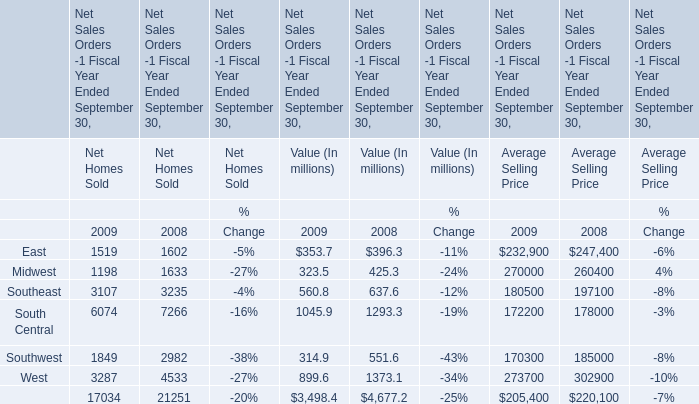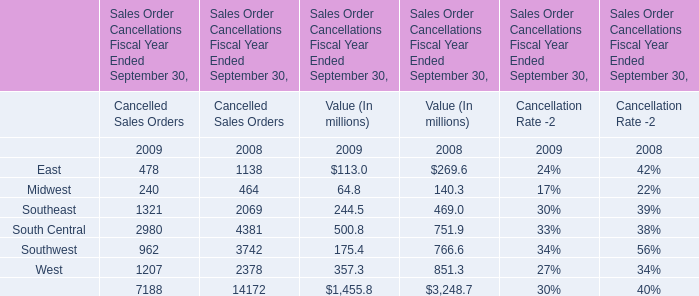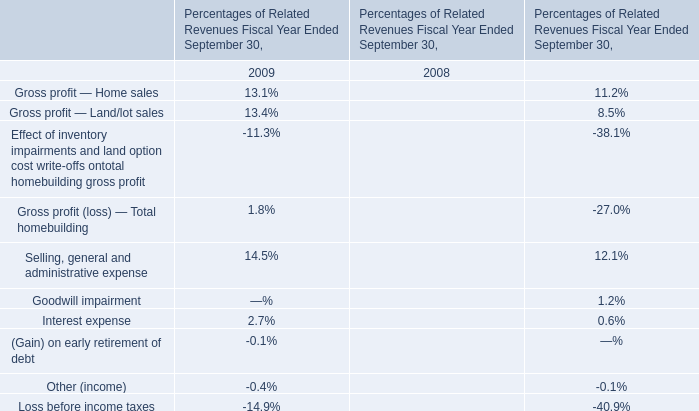What will East for Net Homes Sold reach in 2010 if it continues to grow at its current rate? 
Computations: (1519 * (1 + ((1519 - 1602) / 1602)))
Answer: 1440.30025. 